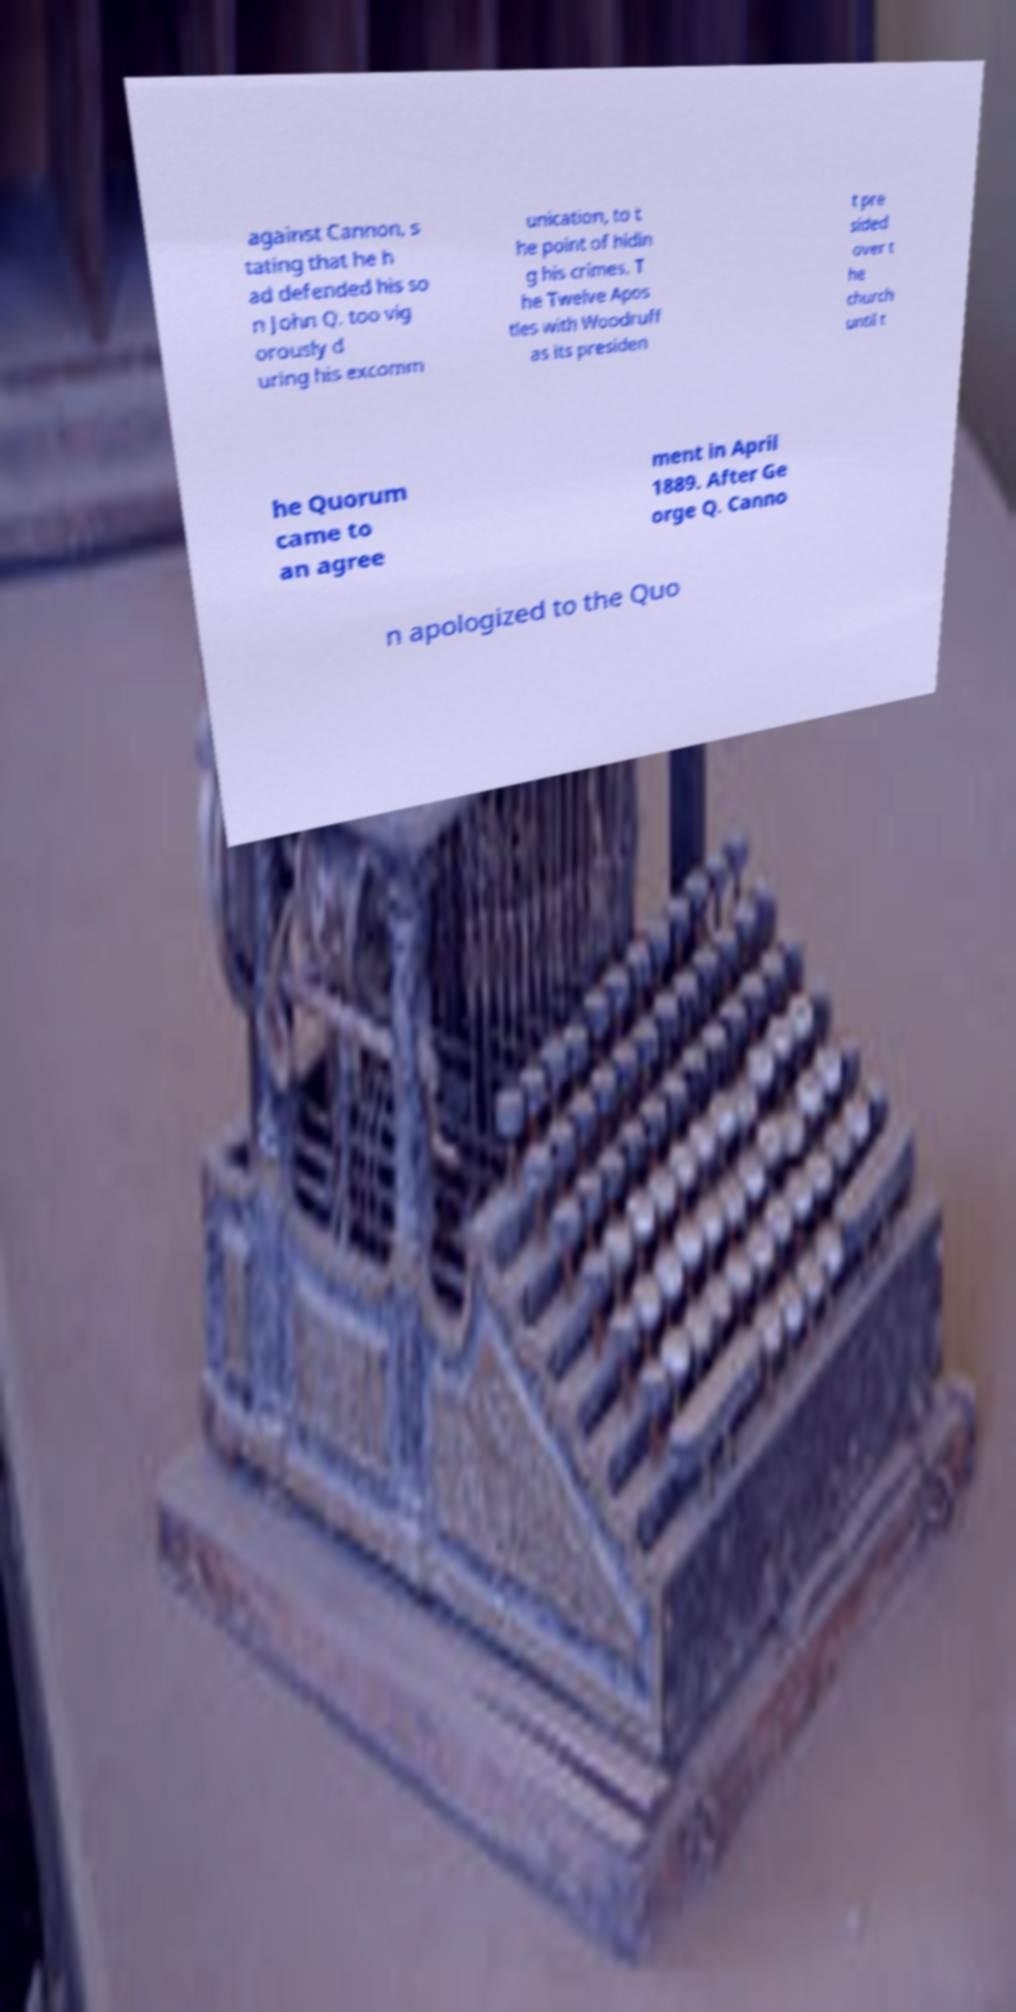For documentation purposes, I need the text within this image transcribed. Could you provide that? against Cannon, s tating that he h ad defended his so n John Q. too vig orously d uring his excomm unication, to t he point of hidin g his crimes. T he Twelve Apos tles with Woodruff as its presiden t pre sided over t he church until t he Quorum came to an agree ment in April 1889. After Ge orge Q. Canno n apologized to the Quo 